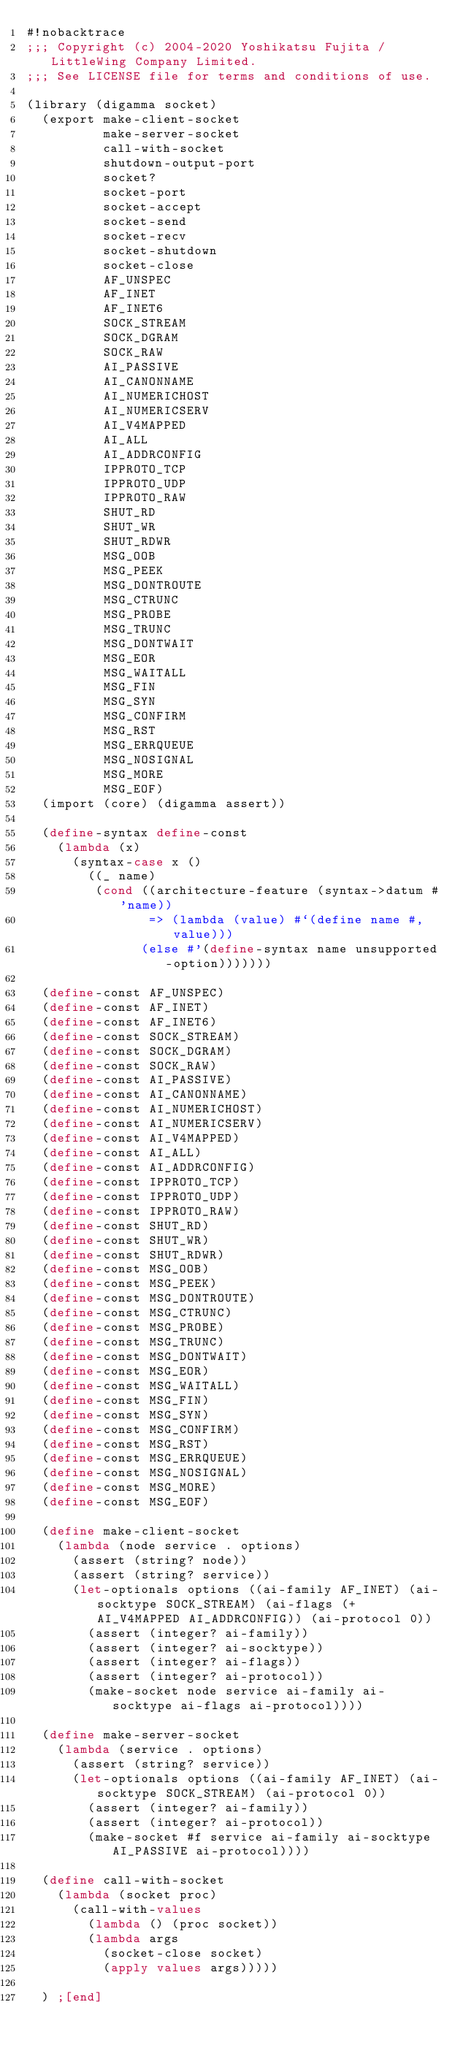<code> <loc_0><loc_0><loc_500><loc_500><_Scheme_>#!nobacktrace
;;; Copyright (c) 2004-2020 Yoshikatsu Fujita / LittleWing Company Limited.
;;; See LICENSE file for terms and conditions of use.

(library (digamma socket)
  (export make-client-socket
          make-server-socket
          call-with-socket
          shutdown-output-port
          socket?
          socket-port
          socket-accept
          socket-send
          socket-recv
          socket-shutdown
          socket-close
          AF_UNSPEC
          AF_INET
          AF_INET6
          SOCK_STREAM
          SOCK_DGRAM
          SOCK_RAW
          AI_PASSIVE
          AI_CANONNAME
          AI_NUMERICHOST
          AI_NUMERICSERV
          AI_V4MAPPED
          AI_ALL
          AI_ADDRCONFIG
          IPPROTO_TCP
          IPPROTO_UDP
          IPPROTO_RAW
          SHUT_RD
          SHUT_WR
          SHUT_RDWR
          MSG_OOB
          MSG_PEEK
          MSG_DONTROUTE
          MSG_CTRUNC
          MSG_PROBE
          MSG_TRUNC
          MSG_DONTWAIT
          MSG_EOR
          MSG_WAITALL
          MSG_FIN
          MSG_SYN
          MSG_CONFIRM
          MSG_RST
          MSG_ERRQUEUE
          MSG_NOSIGNAL
          MSG_MORE
          MSG_EOF)
  (import (core) (digamma assert))

  (define-syntax define-const
    (lambda (x)
      (syntax-case x ()
        ((_ name)
         (cond ((architecture-feature (syntax->datum #'name))
                => (lambda (value) #`(define name #,value)))
               (else #'(define-syntax name unsupported-option)))))))

  (define-const AF_UNSPEC)
  (define-const AF_INET)
  (define-const AF_INET6)
  (define-const SOCK_STREAM)
  (define-const SOCK_DGRAM)
  (define-const SOCK_RAW)
  (define-const AI_PASSIVE)
  (define-const AI_CANONNAME)
  (define-const AI_NUMERICHOST)
  (define-const AI_NUMERICSERV)
  (define-const AI_V4MAPPED)
  (define-const AI_ALL)
  (define-const AI_ADDRCONFIG)
  (define-const IPPROTO_TCP)
  (define-const IPPROTO_UDP)
  (define-const IPPROTO_RAW)
  (define-const SHUT_RD)
  (define-const SHUT_WR)
  (define-const SHUT_RDWR)
  (define-const MSG_OOB)
  (define-const MSG_PEEK)
  (define-const MSG_DONTROUTE)
  (define-const MSG_CTRUNC)
  (define-const MSG_PROBE)
  (define-const MSG_TRUNC)
  (define-const MSG_DONTWAIT)
  (define-const MSG_EOR)
  (define-const MSG_WAITALL)
  (define-const MSG_FIN)
  (define-const MSG_SYN)
  (define-const MSG_CONFIRM)
  (define-const MSG_RST)
  (define-const MSG_ERRQUEUE)
  (define-const MSG_NOSIGNAL)
  (define-const MSG_MORE)
  (define-const MSG_EOF)

  (define make-client-socket
    (lambda (node service . options)
      (assert (string? node))
      (assert (string? service))
      (let-optionals options ((ai-family AF_INET) (ai-socktype SOCK_STREAM) (ai-flags (+ AI_V4MAPPED AI_ADDRCONFIG)) (ai-protocol 0))
        (assert (integer? ai-family))
        (assert (integer? ai-socktype))
        (assert (integer? ai-flags))
        (assert (integer? ai-protocol))
        (make-socket node service ai-family ai-socktype ai-flags ai-protocol))))

  (define make-server-socket
    (lambda (service . options)
      (assert (string? service))
      (let-optionals options ((ai-family AF_INET) (ai-socktype SOCK_STREAM) (ai-protocol 0))
        (assert (integer? ai-family))
        (assert (integer? ai-protocol))
        (make-socket #f service ai-family ai-socktype AI_PASSIVE ai-protocol))))

  (define call-with-socket
    (lambda (socket proc)
      (call-with-values
        (lambda () (proc socket))
        (lambda args
          (socket-close socket)
          (apply values args)))))

  ) ;[end]
</code> 